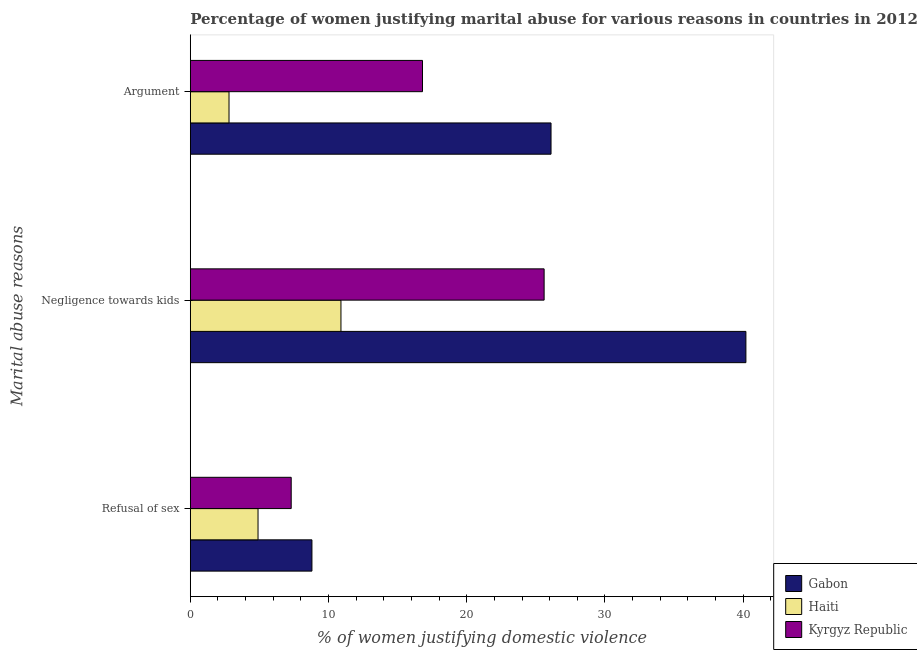Are the number of bars on each tick of the Y-axis equal?
Provide a succinct answer. Yes. What is the label of the 2nd group of bars from the top?
Ensure brevity in your answer.  Negligence towards kids. Across all countries, what is the maximum percentage of women justifying domestic violence due to negligence towards kids?
Provide a short and direct response. 40.2. Across all countries, what is the minimum percentage of women justifying domestic violence due to arguments?
Your answer should be very brief. 2.8. In which country was the percentage of women justifying domestic violence due to negligence towards kids maximum?
Provide a succinct answer. Gabon. In which country was the percentage of women justifying domestic violence due to negligence towards kids minimum?
Provide a succinct answer. Haiti. What is the total percentage of women justifying domestic violence due to arguments in the graph?
Ensure brevity in your answer.  45.7. What is the difference between the percentage of women justifying domestic violence due to arguments in Haiti and that in Kyrgyz Republic?
Give a very brief answer. -14. What is the difference between the percentage of women justifying domestic violence due to refusal of sex in Kyrgyz Republic and the percentage of women justifying domestic violence due to negligence towards kids in Haiti?
Offer a terse response. -3.6. What is the average percentage of women justifying domestic violence due to negligence towards kids per country?
Provide a short and direct response. 25.57. What is the difference between the percentage of women justifying domestic violence due to negligence towards kids and percentage of women justifying domestic violence due to refusal of sex in Gabon?
Give a very brief answer. 31.4. What is the ratio of the percentage of women justifying domestic violence due to refusal of sex in Haiti to that in Gabon?
Ensure brevity in your answer.  0.56. Is the difference between the percentage of women justifying domestic violence due to negligence towards kids in Gabon and Haiti greater than the difference between the percentage of women justifying domestic violence due to refusal of sex in Gabon and Haiti?
Provide a short and direct response. Yes. What is the difference between the highest and the second highest percentage of women justifying domestic violence due to negligence towards kids?
Provide a short and direct response. 14.6. What is the difference between the highest and the lowest percentage of women justifying domestic violence due to arguments?
Keep it short and to the point. 23.3. In how many countries, is the percentage of women justifying domestic violence due to negligence towards kids greater than the average percentage of women justifying domestic violence due to negligence towards kids taken over all countries?
Offer a terse response. 2. Is the sum of the percentage of women justifying domestic violence due to negligence towards kids in Haiti and Gabon greater than the maximum percentage of women justifying domestic violence due to refusal of sex across all countries?
Make the answer very short. Yes. What does the 2nd bar from the top in Negligence towards kids represents?
Offer a terse response. Haiti. What does the 1st bar from the bottom in Refusal of sex represents?
Your answer should be compact. Gabon. How many countries are there in the graph?
Give a very brief answer. 3. What is the difference between two consecutive major ticks on the X-axis?
Offer a terse response. 10. Does the graph contain grids?
Provide a short and direct response. No. Where does the legend appear in the graph?
Provide a short and direct response. Bottom right. What is the title of the graph?
Give a very brief answer. Percentage of women justifying marital abuse for various reasons in countries in 2012. Does "Sao Tome and Principe" appear as one of the legend labels in the graph?
Provide a succinct answer. No. What is the label or title of the X-axis?
Make the answer very short. % of women justifying domestic violence. What is the label or title of the Y-axis?
Keep it short and to the point. Marital abuse reasons. What is the % of women justifying domestic violence of Gabon in Negligence towards kids?
Your answer should be very brief. 40.2. What is the % of women justifying domestic violence in Haiti in Negligence towards kids?
Provide a succinct answer. 10.9. What is the % of women justifying domestic violence in Kyrgyz Republic in Negligence towards kids?
Offer a terse response. 25.6. What is the % of women justifying domestic violence of Gabon in Argument?
Make the answer very short. 26.1. What is the % of women justifying domestic violence in Kyrgyz Republic in Argument?
Provide a succinct answer. 16.8. Across all Marital abuse reasons, what is the maximum % of women justifying domestic violence of Gabon?
Offer a very short reply. 40.2. Across all Marital abuse reasons, what is the maximum % of women justifying domestic violence of Haiti?
Your answer should be very brief. 10.9. Across all Marital abuse reasons, what is the maximum % of women justifying domestic violence in Kyrgyz Republic?
Provide a succinct answer. 25.6. What is the total % of women justifying domestic violence in Gabon in the graph?
Provide a short and direct response. 75.1. What is the total % of women justifying domestic violence of Haiti in the graph?
Your answer should be very brief. 18.6. What is the total % of women justifying domestic violence of Kyrgyz Republic in the graph?
Offer a terse response. 49.7. What is the difference between the % of women justifying domestic violence in Gabon in Refusal of sex and that in Negligence towards kids?
Keep it short and to the point. -31.4. What is the difference between the % of women justifying domestic violence in Kyrgyz Republic in Refusal of sex and that in Negligence towards kids?
Offer a very short reply. -18.3. What is the difference between the % of women justifying domestic violence in Gabon in Refusal of sex and that in Argument?
Give a very brief answer. -17.3. What is the difference between the % of women justifying domestic violence in Gabon in Negligence towards kids and that in Argument?
Your answer should be very brief. 14.1. What is the difference between the % of women justifying domestic violence in Haiti in Negligence towards kids and that in Argument?
Provide a succinct answer. 8.1. What is the difference between the % of women justifying domestic violence in Gabon in Refusal of sex and the % of women justifying domestic violence in Haiti in Negligence towards kids?
Provide a succinct answer. -2.1. What is the difference between the % of women justifying domestic violence of Gabon in Refusal of sex and the % of women justifying domestic violence of Kyrgyz Republic in Negligence towards kids?
Your answer should be very brief. -16.8. What is the difference between the % of women justifying domestic violence of Haiti in Refusal of sex and the % of women justifying domestic violence of Kyrgyz Republic in Negligence towards kids?
Ensure brevity in your answer.  -20.7. What is the difference between the % of women justifying domestic violence in Gabon in Refusal of sex and the % of women justifying domestic violence in Haiti in Argument?
Provide a succinct answer. 6. What is the difference between the % of women justifying domestic violence of Gabon in Negligence towards kids and the % of women justifying domestic violence of Haiti in Argument?
Ensure brevity in your answer.  37.4. What is the difference between the % of women justifying domestic violence of Gabon in Negligence towards kids and the % of women justifying domestic violence of Kyrgyz Republic in Argument?
Give a very brief answer. 23.4. What is the difference between the % of women justifying domestic violence in Haiti in Negligence towards kids and the % of women justifying domestic violence in Kyrgyz Republic in Argument?
Offer a terse response. -5.9. What is the average % of women justifying domestic violence of Gabon per Marital abuse reasons?
Your response must be concise. 25.03. What is the average % of women justifying domestic violence in Kyrgyz Republic per Marital abuse reasons?
Ensure brevity in your answer.  16.57. What is the difference between the % of women justifying domestic violence of Gabon and % of women justifying domestic violence of Kyrgyz Republic in Refusal of sex?
Your response must be concise. 1.5. What is the difference between the % of women justifying domestic violence in Haiti and % of women justifying domestic violence in Kyrgyz Republic in Refusal of sex?
Your answer should be compact. -2.4. What is the difference between the % of women justifying domestic violence of Gabon and % of women justifying domestic violence of Haiti in Negligence towards kids?
Give a very brief answer. 29.3. What is the difference between the % of women justifying domestic violence of Haiti and % of women justifying domestic violence of Kyrgyz Republic in Negligence towards kids?
Your answer should be compact. -14.7. What is the difference between the % of women justifying domestic violence of Gabon and % of women justifying domestic violence of Haiti in Argument?
Ensure brevity in your answer.  23.3. What is the difference between the % of women justifying domestic violence in Gabon and % of women justifying domestic violence in Kyrgyz Republic in Argument?
Your answer should be very brief. 9.3. What is the ratio of the % of women justifying domestic violence of Gabon in Refusal of sex to that in Negligence towards kids?
Make the answer very short. 0.22. What is the ratio of the % of women justifying domestic violence in Haiti in Refusal of sex to that in Negligence towards kids?
Make the answer very short. 0.45. What is the ratio of the % of women justifying domestic violence in Kyrgyz Republic in Refusal of sex to that in Negligence towards kids?
Provide a short and direct response. 0.29. What is the ratio of the % of women justifying domestic violence of Gabon in Refusal of sex to that in Argument?
Make the answer very short. 0.34. What is the ratio of the % of women justifying domestic violence in Kyrgyz Republic in Refusal of sex to that in Argument?
Give a very brief answer. 0.43. What is the ratio of the % of women justifying domestic violence of Gabon in Negligence towards kids to that in Argument?
Your response must be concise. 1.54. What is the ratio of the % of women justifying domestic violence in Haiti in Negligence towards kids to that in Argument?
Your response must be concise. 3.89. What is the ratio of the % of women justifying domestic violence in Kyrgyz Republic in Negligence towards kids to that in Argument?
Your answer should be compact. 1.52. What is the difference between the highest and the second highest % of women justifying domestic violence of Haiti?
Your answer should be compact. 6. What is the difference between the highest and the lowest % of women justifying domestic violence in Gabon?
Make the answer very short. 31.4. What is the difference between the highest and the lowest % of women justifying domestic violence of Kyrgyz Republic?
Provide a short and direct response. 18.3. 